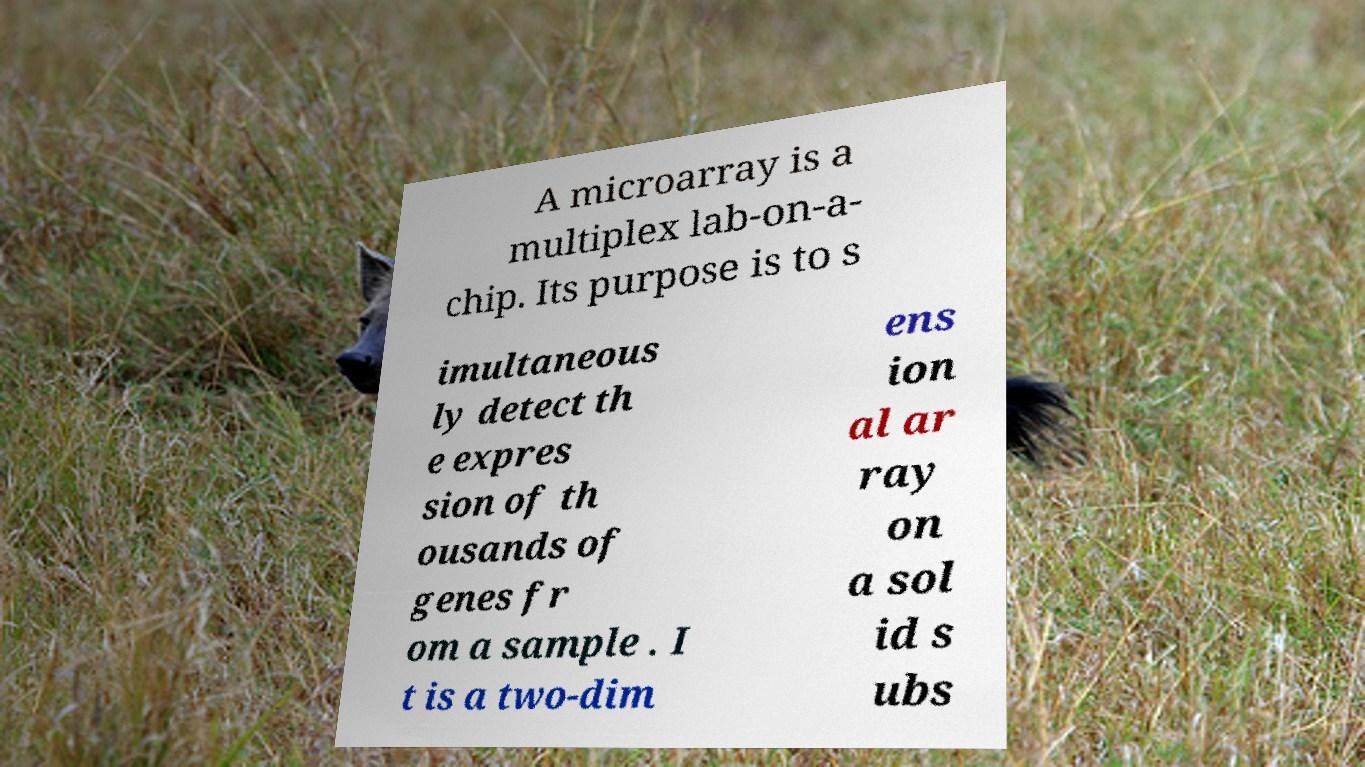Can you read and provide the text displayed in the image?This photo seems to have some interesting text. Can you extract and type it out for me? A microarray is a multiplex lab-on-a- chip. Its purpose is to s imultaneous ly detect th e expres sion of th ousands of genes fr om a sample . I t is a two-dim ens ion al ar ray on a sol id s ubs 